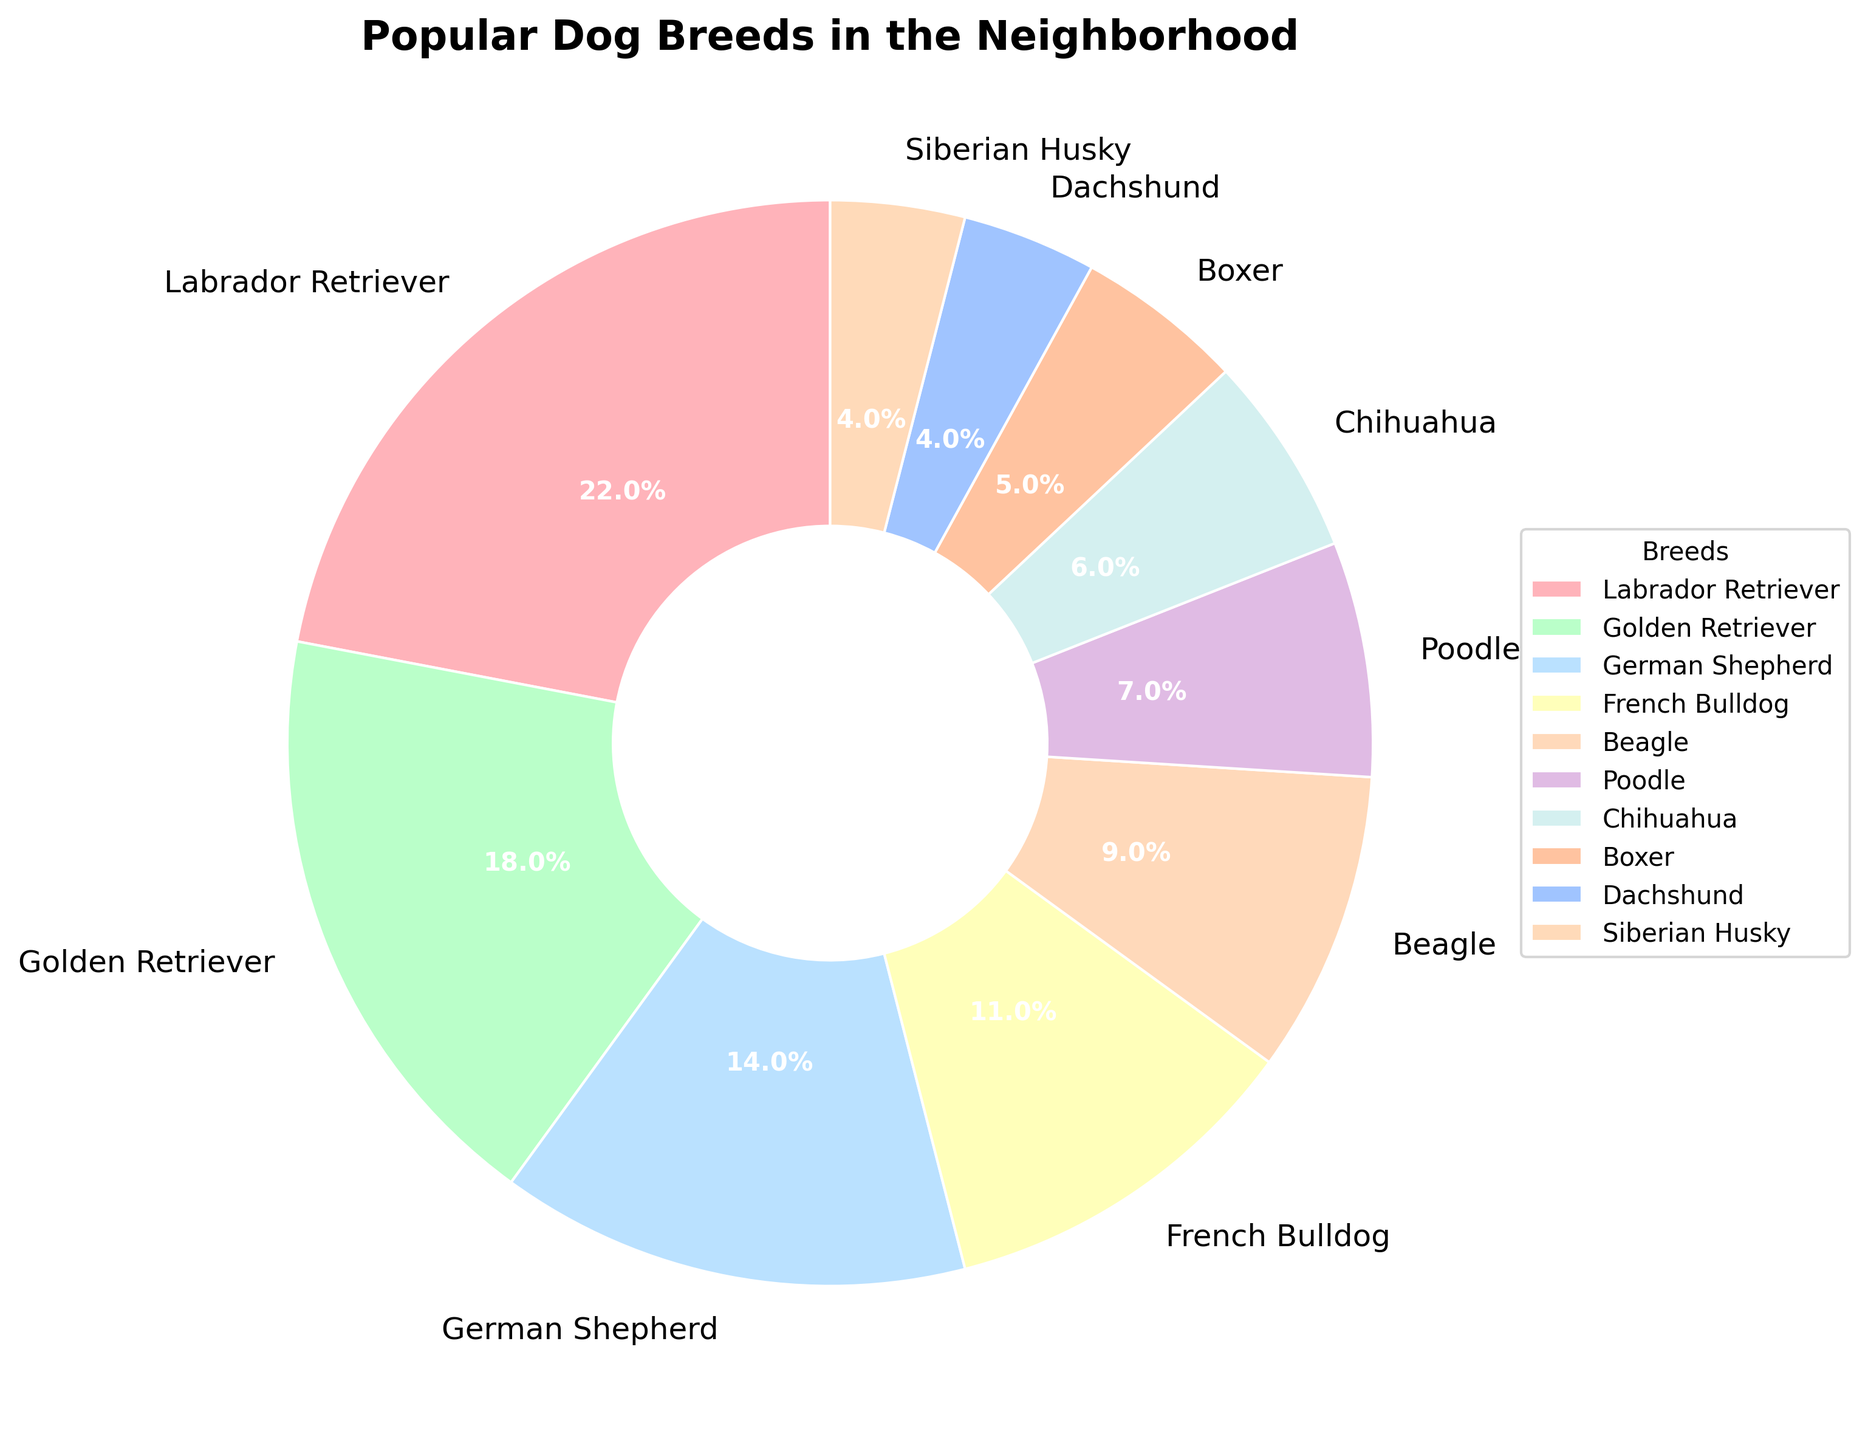Which breed has the highest percentage in the neighborhood? The chart shows that the Labrador Retriever has the largest section, labeled with 22%.
Answer: Labrador Retriever How much more popular is the Golden Retriever compared to the Boxer? The Golden Retriever has 18% while the Boxer has 5%. The difference in their popularity is 18% - 5%.
Answer: 13% What is the combined percentage of the top three dog breeds? The top three breeds are Labrador Retriever (22%), Golden Retriever (18%), and German Shepherd (14%). Adding them together gives 22% + 18% + 14%.
Answer: 54% Are there more Beagles or Poodles in the neighborhood, and by how much? The chart shows Beagles at 9% and Poodles at 7%. The difference is 9% - 7%.
Answer: Beagles by 2% Which breed has the smallest percentage and what is it? The smallest section of the chart represents the Dachshund and the Siberian Husky, both with 4%.
Answer: Dachshund and Siberian Husky, 4% How does the percentage of French Bulldogs compare to German Shepherds? The French Bulldog section shows 11%, while the German Shepherd section shows 14%. The German Shepherds are 3% more popular than the French Bulldogs.
Answer: German Shepherds by 3% What's the total percentage of all breeds less popular than the Beagle? Breeds less popular than the Beagle (9%) are Poodle (7%), Chihuahua (6%), Boxer (5%), Dachshund (4%), and Siberian Husky (4%). Summing these percentages: 7% + 6% + 5% + 4% + 4%.
Answer: 26% Which breed appears in a peach color on the chart? By referring to the color descriptions, the dachshund section is peach-colored on the chart, which matches the peach color description.
Answer: Dachshund If you group Poodles, Chihuahuas, and Boxers together, what is their combined percentage? Adding the percentages of Poodle (7%), Chihuahua (6%), and Boxer (5%) together gives 7% + 6% + 5%.
Answer: 18% Is there an equal percentage for any two dog breeds? The chart shows that Dachshund and Siberian Husky both have a section labeled with 4%.
Answer: Yes, Dachshund and Siberian Husky 